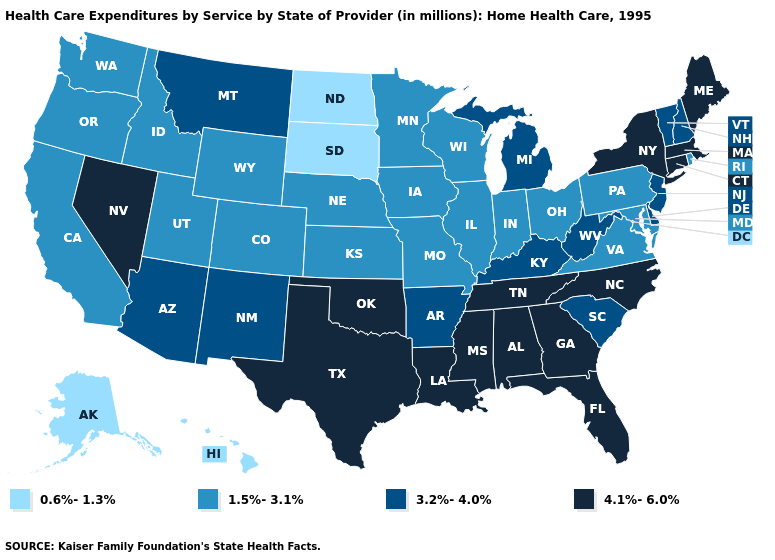Does Virginia have the highest value in the USA?
Write a very short answer. No. Does the map have missing data?
Concise answer only. No. Does New Jersey have the same value as Idaho?
Concise answer only. No. Name the states that have a value in the range 3.2%-4.0%?
Short answer required. Arizona, Arkansas, Delaware, Kentucky, Michigan, Montana, New Hampshire, New Jersey, New Mexico, South Carolina, Vermont, West Virginia. Name the states that have a value in the range 3.2%-4.0%?
Answer briefly. Arizona, Arkansas, Delaware, Kentucky, Michigan, Montana, New Hampshire, New Jersey, New Mexico, South Carolina, Vermont, West Virginia. What is the value of Iowa?
Concise answer only. 1.5%-3.1%. Which states have the highest value in the USA?
Write a very short answer. Alabama, Connecticut, Florida, Georgia, Louisiana, Maine, Massachusetts, Mississippi, Nevada, New York, North Carolina, Oklahoma, Tennessee, Texas. What is the value of Oregon?
Answer briefly. 1.5%-3.1%. Is the legend a continuous bar?
Give a very brief answer. No. Does Missouri have the lowest value in the USA?
Quick response, please. No. Among the states that border Nevada , which have the highest value?
Concise answer only. Arizona. Which states hav the highest value in the West?
Be succinct. Nevada. Name the states that have a value in the range 0.6%-1.3%?
Write a very short answer. Alaska, Hawaii, North Dakota, South Dakota. What is the value of Iowa?
Concise answer only. 1.5%-3.1%. Name the states that have a value in the range 0.6%-1.3%?
Answer briefly. Alaska, Hawaii, North Dakota, South Dakota. 